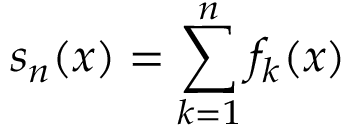<formula> <loc_0><loc_0><loc_500><loc_500>s _ { n } ( x ) = \sum _ { k = 1 } ^ { n } f _ { k } ( x )</formula> 